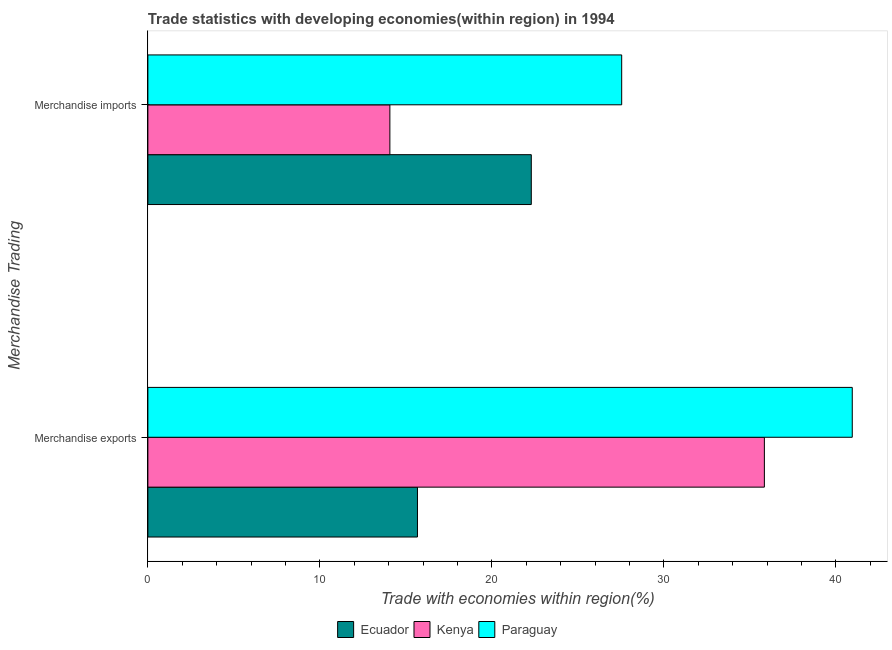How many different coloured bars are there?
Provide a short and direct response. 3. Are the number of bars per tick equal to the number of legend labels?
Ensure brevity in your answer.  Yes. Are the number of bars on each tick of the Y-axis equal?
Make the answer very short. Yes. How many bars are there on the 2nd tick from the top?
Ensure brevity in your answer.  3. What is the label of the 2nd group of bars from the top?
Give a very brief answer. Merchandise exports. What is the merchandise exports in Ecuador?
Offer a terse response. 15.67. Across all countries, what is the maximum merchandise imports?
Ensure brevity in your answer.  27.55. Across all countries, what is the minimum merchandise imports?
Your answer should be very brief. 14.07. In which country was the merchandise imports maximum?
Your answer should be compact. Paraguay. In which country was the merchandise imports minimum?
Give a very brief answer. Kenya. What is the total merchandise exports in the graph?
Provide a succinct answer. 92.47. What is the difference between the merchandise exports in Kenya and that in Paraguay?
Your answer should be compact. -5.11. What is the difference between the merchandise imports in Paraguay and the merchandise exports in Kenya?
Ensure brevity in your answer.  -8.3. What is the average merchandise imports per country?
Offer a terse response. 21.3. What is the difference between the merchandise exports and merchandise imports in Kenya?
Ensure brevity in your answer.  21.77. What is the ratio of the merchandise exports in Paraguay to that in Kenya?
Provide a succinct answer. 1.14. Is the merchandise imports in Paraguay less than that in Ecuador?
Provide a succinct answer. No. What does the 1st bar from the top in Merchandise exports represents?
Make the answer very short. Paraguay. What does the 3rd bar from the bottom in Merchandise imports represents?
Offer a very short reply. Paraguay. How many bars are there?
Offer a very short reply. 6. How many countries are there in the graph?
Provide a short and direct response. 3. Does the graph contain grids?
Your answer should be very brief. No. Where does the legend appear in the graph?
Keep it short and to the point. Bottom center. How many legend labels are there?
Your response must be concise. 3. What is the title of the graph?
Ensure brevity in your answer.  Trade statistics with developing economies(within region) in 1994. What is the label or title of the X-axis?
Ensure brevity in your answer.  Trade with economies within region(%). What is the label or title of the Y-axis?
Provide a succinct answer. Merchandise Trading. What is the Trade with economies within region(%) of Ecuador in Merchandise exports?
Provide a short and direct response. 15.67. What is the Trade with economies within region(%) of Kenya in Merchandise exports?
Offer a terse response. 35.84. What is the Trade with economies within region(%) in Paraguay in Merchandise exports?
Your answer should be very brief. 40.95. What is the Trade with economies within region(%) of Ecuador in Merchandise imports?
Provide a short and direct response. 22.29. What is the Trade with economies within region(%) of Kenya in Merchandise imports?
Your response must be concise. 14.07. What is the Trade with economies within region(%) in Paraguay in Merchandise imports?
Your answer should be very brief. 27.55. Across all Merchandise Trading, what is the maximum Trade with economies within region(%) in Ecuador?
Your answer should be very brief. 22.29. Across all Merchandise Trading, what is the maximum Trade with economies within region(%) in Kenya?
Offer a terse response. 35.84. Across all Merchandise Trading, what is the maximum Trade with economies within region(%) in Paraguay?
Your response must be concise. 40.95. Across all Merchandise Trading, what is the minimum Trade with economies within region(%) of Ecuador?
Provide a succinct answer. 15.67. Across all Merchandise Trading, what is the minimum Trade with economies within region(%) of Kenya?
Your answer should be very brief. 14.07. Across all Merchandise Trading, what is the minimum Trade with economies within region(%) in Paraguay?
Your answer should be compact. 27.55. What is the total Trade with economies within region(%) of Ecuador in the graph?
Your response must be concise. 37.97. What is the total Trade with economies within region(%) in Kenya in the graph?
Provide a short and direct response. 49.91. What is the total Trade with economies within region(%) in Paraguay in the graph?
Keep it short and to the point. 68.5. What is the difference between the Trade with economies within region(%) of Ecuador in Merchandise exports and that in Merchandise imports?
Offer a terse response. -6.62. What is the difference between the Trade with economies within region(%) in Kenya in Merchandise exports and that in Merchandise imports?
Make the answer very short. 21.77. What is the difference between the Trade with economies within region(%) of Paraguay in Merchandise exports and that in Merchandise imports?
Offer a terse response. 13.41. What is the difference between the Trade with economies within region(%) in Ecuador in Merchandise exports and the Trade with economies within region(%) in Kenya in Merchandise imports?
Keep it short and to the point. 1.6. What is the difference between the Trade with economies within region(%) in Ecuador in Merchandise exports and the Trade with economies within region(%) in Paraguay in Merchandise imports?
Ensure brevity in your answer.  -11.87. What is the difference between the Trade with economies within region(%) of Kenya in Merchandise exports and the Trade with economies within region(%) of Paraguay in Merchandise imports?
Your answer should be very brief. 8.3. What is the average Trade with economies within region(%) of Ecuador per Merchandise Trading?
Your response must be concise. 18.98. What is the average Trade with economies within region(%) in Kenya per Merchandise Trading?
Ensure brevity in your answer.  24.96. What is the average Trade with economies within region(%) in Paraguay per Merchandise Trading?
Your response must be concise. 34.25. What is the difference between the Trade with economies within region(%) of Ecuador and Trade with economies within region(%) of Kenya in Merchandise exports?
Your answer should be compact. -20.17. What is the difference between the Trade with economies within region(%) in Ecuador and Trade with economies within region(%) in Paraguay in Merchandise exports?
Make the answer very short. -25.28. What is the difference between the Trade with economies within region(%) of Kenya and Trade with economies within region(%) of Paraguay in Merchandise exports?
Your response must be concise. -5.11. What is the difference between the Trade with economies within region(%) of Ecuador and Trade with economies within region(%) of Kenya in Merchandise imports?
Make the answer very short. 8.22. What is the difference between the Trade with economies within region(%) of Ecuador and Trade with economies within region(%) of Paraguay in Merchandise imports?
Your response must be concise. -5.25. What is the difference between the Trade with economies within region(%) in Kenya and Trade with economies within region(%) in Paraguay in Merchandise imports?
Provide a succinct answer. -13.48. What is the ratio of the Trade with economies within region(%) of Ecuador in Merchandise exports to that in Merchandise imports?
Give a very brief answer. 0.7. What is the ratio of the Trade with economies within region(%) in Kenya in Merchandise exports to that in Merchandise imports?
Your response must be concise. 2.55. What is the ratio of the Trade with economies within region(%) in Paraguay in Merchandise exports to that in Merchandise imports?
Offer a very short reply. 1.49. What is the difference between the highest and the second highest Trade with economies within region(%) in Ecuador?
Keep it short and to the point. 6.62. What is the difference between the highest and the second highest Trade with economies within region(%) in Kenya?
Make the answer very short. 21.77. What is the difference between the highest and the second highest Trade with economies within region(%) of Paraguay?
Keep it short and to the point. 13.41. What is the difference between the highest and the lowest Trade with economies within region(%) in Ecuador?
Keep it short and to the point. 6.62. What is the difference between the highest and the lowest Trade with economies within region(%) in Kenya?
Ensure brevity in your answer.  21.77. What is the difference between the highest and the lowest Trade with economies within region(%) in Paraguay?
Your answer should be very brief. 13.41. 